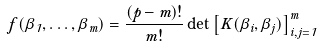Convert formula to latex. <formula><loc_0><loc_0><loc_500><loc_500>f ( \beta _ { 1 } , \dots , \beta _ { m } ) = \frac { ( p - m ) ! } { m ! } \det \left [ K ( \beta _ { i } , \beta _ { j } ) \right ] _ { i , j = 1 } ^ { m }</formula> 